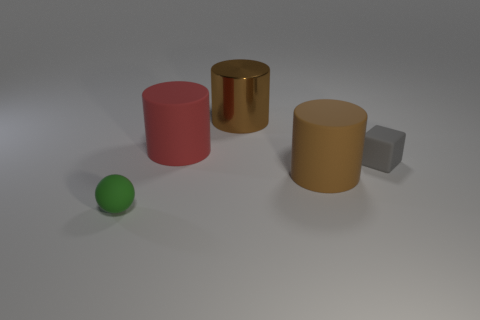What is the small gray object made of?
Ensure brevity in your answer.  Rubber. Is there any other thing that has the same color as the small ball?
Provide a succinct answer. No. Is the small green thing made of the same material as the large red object?
Your response must be concise. Yes. There is a small matte object that is on the right side of the small rubber thing that is in front of the tiny matte cube; how many big objects are behind it?
Provide a short and direct response. 2. How many large purple metal balls are there?
Your answer should be very brief. 0. Are there fewer brown shiny objects behind the brown shiny object than red cylinders that are behind the big red object?
Keep it short and to the point. No. Is the number of tiny rubber things on the left side of the large red thing less than the number of purple rubber balls?
Your answer should be compact. No. What is the material of the thing in front of the brown cylinder that is in front of the big brown cylinder that is behind the small gray cube?
Offer a terse response. Rubber. How many objects are either small objects in front of the metal cylinder or things behind the small ball?
Ensure brevity in your answer.  5. There is a big red thing that is the same shape as the large brown matte thing; what is its material?
Give a very brief answer. Rubber. 